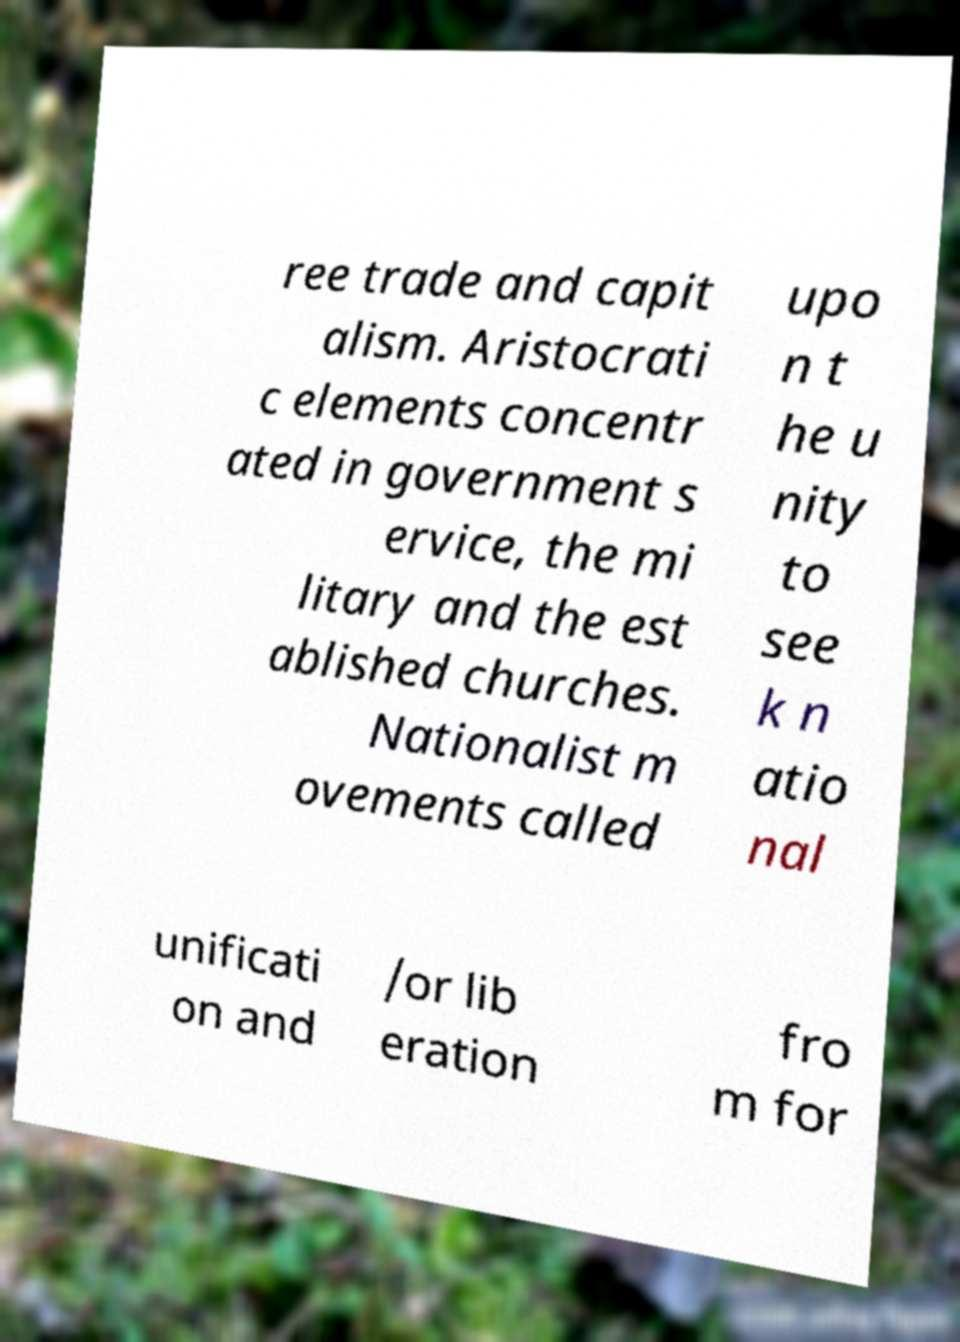Please identify and transcribe the text found in this image. ree trade and capit alism. Aristocrati c elements concentr ated in government s ervice, the mi litary and the est ablished churches. Nationalist m ovements called upo n t he u nity to see k n atio nal unificati on and /or lib eration fro m for 